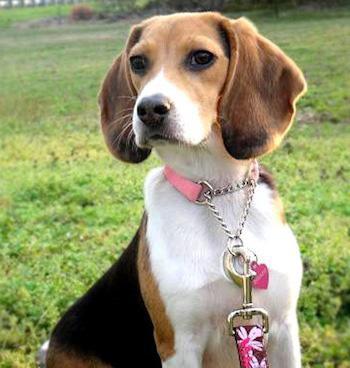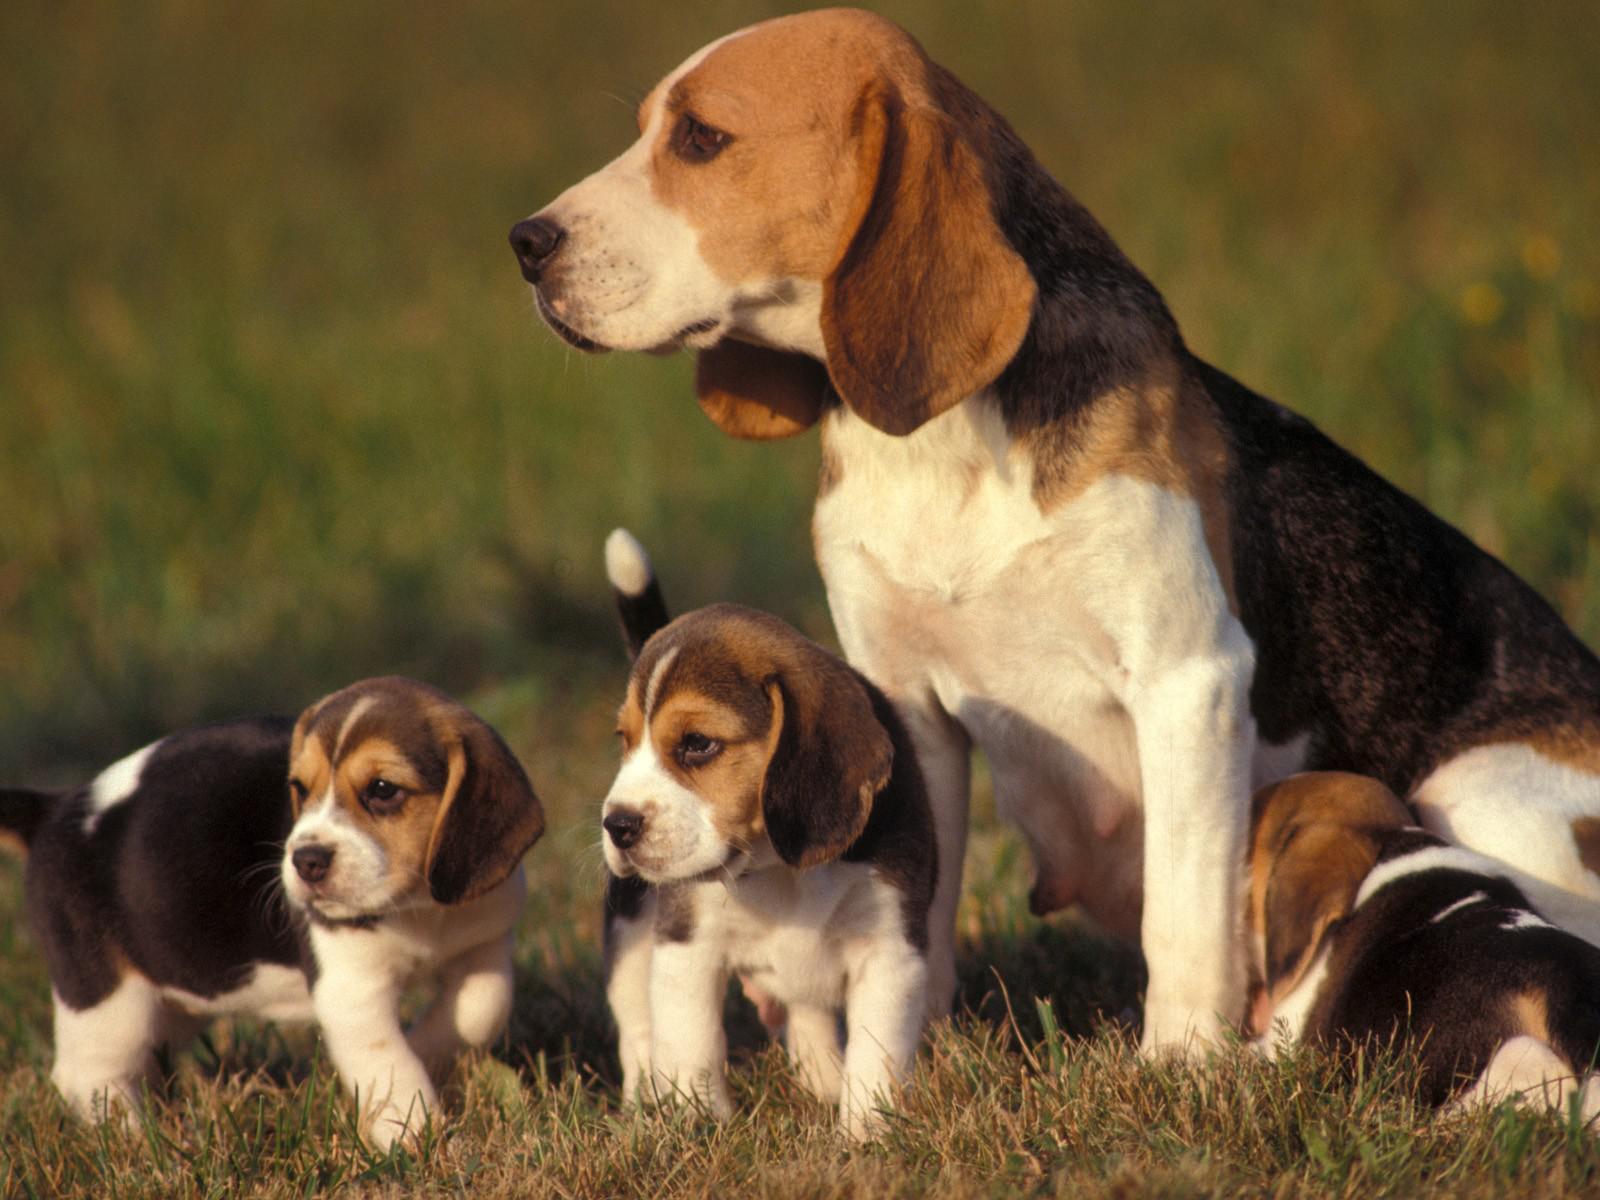The first image is the image on the left, the second image is the image on the right. Given the left and right images, does the statement "There is at least one puppy in one of the pictures." hold true? Answer yes or no. Yes. The first image is the image on the left, the second image is the image on the right. For the images shown, is this caption "a beagle sitting in the grass has dog tags on it's collar" true? Answer yes or no. Yes. 